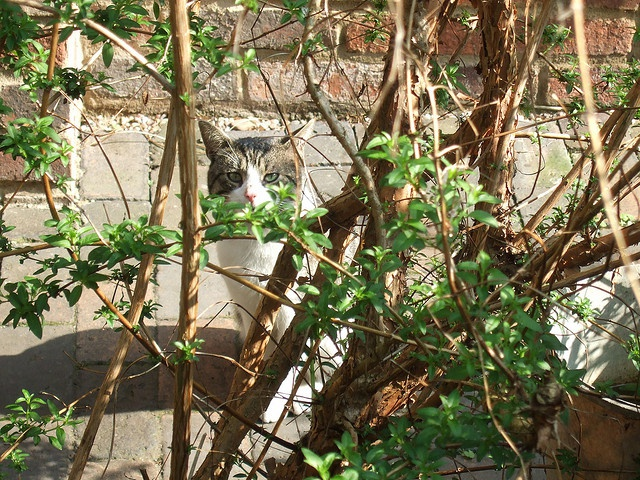Describe the objects in this image and their specific colors. I can see a cat in darkgreen, black, ivory, and maroon tones in this image. 